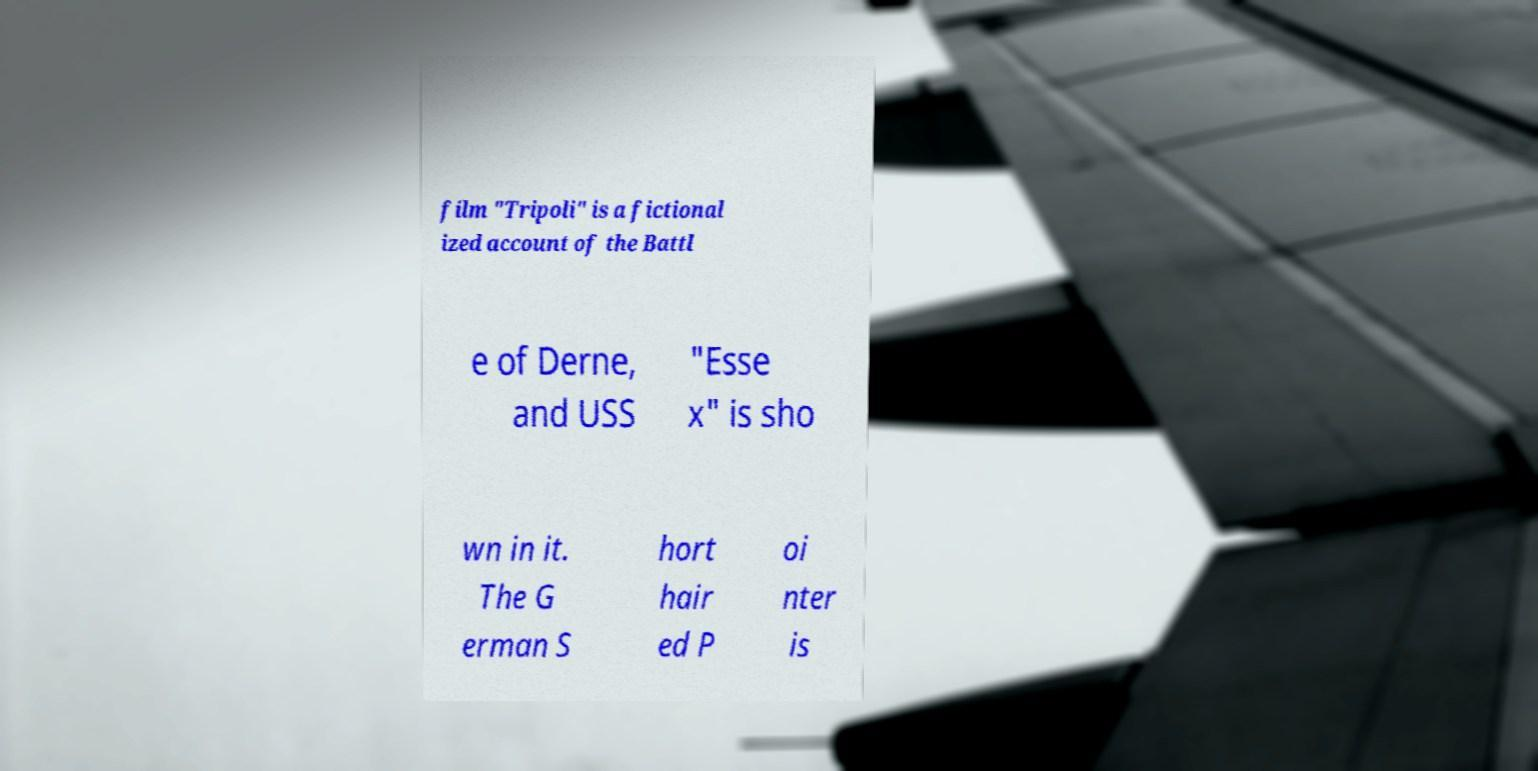Could you extract and type out the text from this image? film "Tripoli" is a fictional ized account of the Battl e of Derne, and USS "Esse x" is sho wn in it. The G erman S hort hair ed P oi nter is 